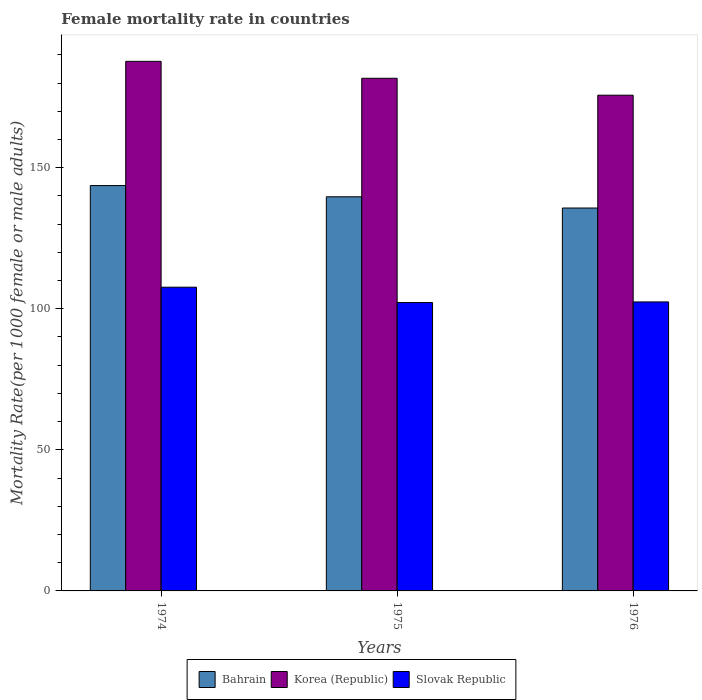How many different coloured bars are there?
Offer a terse response. 3. How many groups of bars are there?
Ensure brevity in your answer.  3. Are the number of bars per tick equal to the number of legend labels?
Offer a very short reply. Yes. How many bars are there on the 2nd tick from the right?
Your answer should be very brief. 3. What is the label of the 3rd group of bars from the left?
Keep it short and to the point. 1976. In how many cases, is the number of bars for a given year not equal to the number of legend labels?
Offer a terse response. 0. What is the female mortality rate in Bahrain in 1975?
Keep it short and to the point. 139.69. Across all years, what is the maximum female mortality rate in Slovak Republic?
Provide a short and direct response. 107.65. Across all years, what is the minimum female mortality rate in Slovak Republic?
Provide a short and direct response. 102.21. In which year was the female mortality rate in Slovak Republic maximum?
Keep it short and to the point. 1974. In which year was the female mortality rate in Bahrain minimum?
Your answer should be very brief. 1976. What is the total female mortality rate in Bahrain in the graph?
Your response must be concise. 419.07. What is the difference between the female mortality rate in Korea (Republic) in 1974 and that in 1975?
Provide a succinct answer. 6. What is the difference between the female mortality rate in Korea (Republic) in 1976 and the female mortality rate in Slovak Republic in 1974?
Offer a terse response. 68.05. What is the average female mortality rate in Slovak Republic per year?
Make the answer very short. 104.09. In the year 1976, what is the difference between the female mortality rate in Korea (Republic) and female mortality rate in Slovak Republic?
Provide a short and direct response. 73.27. In how many years, is the female mortality rate in Korea (Republic) greater than 50?
Offer a terse response. 3. What is the ratio of the female mortality rate in Korea (Republic) in 1975 to that in 1976?
Your answer should be very brief. 1.03. Is the female mortality rate in Slovak Republic in 1975 less than that in 1976?
Provide a succinct answer. Yes. Is the difference between the female mortality rate in Korea (Republic) in 1974 and 1976 greater than the difference between the female mortality rate in Slovak Republic in 1974 and 1976?
Make the answer very short. Yes. What is the difference between the highest and the second highest female mortality rate in Bahrain?
Provide a succinct answer. 3.98. What is the difference between the highest and the lowest female mortality rate in Korea (Republic)?
Offer a terse response. 11.99. What does the 1st bar from the right in 1976 represents?
Provide a succinct answer. Slovak Republic. Is it the case that in every year, the sum of the female mortality rate in Bahrain and female mortality rate in Slovak Republic is greater than the female mortality rate in Korea (Republic)?
Your answer should be very brief. Yes. Are all the bars in the graph horizontal?
Give a very brief answer. No. How many years are there in the graph?
Your answer should be very brief. 3. What is the difference between two consecutive major ticks on the Y-axis?
Keep it short and to the point. 50. Does the graph contain any zero values?
Give a very brief answer. No. Does the graph contain grids?
Your answer should be compact. No. How are the legend labels stacked?
Make the answer very short. Horizontal. What is the title of the graph?
Ensure brevity in your answer.  Female mortality rate in countries. What is the label or title of the X-axis?
Keep it short and to the point. Years. What is the label or title of the Y-axis?
Keep it short and to the point. Mortality Rate(per 1000 female or male adults). What is the Mortality Rate(per 1000 female or male adults) in Bahrain in 1974?
Offer a terse response. 143.67. What is the Mortality Rate(per 1000 female or male adults) of Korea (Republic) in 1974?
Keep it short and to the point. 187.69. What is the Mortality Rate(per 1000 female or male adults) in Slovak Republic in 1974?
Make the answer very short. 107.65. What is the Mortality Rate(per 1000 female or male adults) in Bahrain in 1975?
Your answer should be very brief. 139.69. What is the Mortality Rate(per 1000 female or male adults) in Korea (Republic) in 1975?
Your answer should be compact. 181.69. What is the Mortality Rate(per 1000 female or male adults) of Slovak Republic in 1975?
Your answer should be compact. 102.21. What is the Mortality Rate(per 1000 female or male adults) of Bahrain in 1976?
Offer a very short reply. 135.71. What is the Mortality Rate(per 1000 female or male adults) of Korea (Republic) in 1976?
Offer a terse response. 175.7. What is the Mortality Rate(per 1000 female or male adults) in Slovak Republic in 1976?
Your response must be concise. 102.43. Across all years, what is the maximum Mortality Rate(per 1000 female or male adults) of Bahrain?
Make the answer very short. 143.67. Across all years, what is the maximum Mortality Rate(per 1000 female or male adults) in Korea (Republic)?
Your response must be concise. 187.69. Across all years, what is the maximum Mortality Rate(per 1000 female or male adults) in Slovak Republic?
Your answer should be compact. 107.65. Across all years, what is the minimum Mortality Rate(per 1000 female or male adults) of Bahrain?
Make the answer very short. 135.71. Across all years, what is the minimum Mortality Rate(per 1000 female or male adults) of Korea (Republic)?
Give a very brief answer. 175.7. Across all years, what is the minimum Mortality Rate(per 1000 female or male adults) of Slovak Republic?
Your answer should be very brief. 102.21. What is the total Mortality Rate(per 1000 female or male adults) in Bahrain in the graph?
Provide a short and direct response. 419.07. What is the total Mortality Rate(per 1000 female or male adults) of Korea (Republic) in the graph?
Your answer should be compact. 545.08. What is the total Mortality Rate(per 1000 female or male adults) in Slovak Republic in the graph?
Your answer should be compact. 312.28. What is the difference between the Mortality Rate(per 1000 female or male adults) of Bahrain in 1974 and that in 1975?
Give a very brief answer. 3.98. What is the difference between the Mortality Rate(per 1000 female or male adults) of Korea (Republic) in 1974 and that in 1975?
Ensure brevity in your answer.  6. What is the difference between the Mortality Rate(per 1000 female or male adults) in Slovak Republic in 1974 and that in 1975?
Provide a short and direct response. 5.43. What is the difference between the Mortality Rate(per 1000 female or male adults) in Bahrain in 1974 and that in 1976?
Your response must be concise. 7.97. What is the difference between the Mortality Rate(per 1000 female or male adults) of Korea (Republic) in 1974 and that in 1976?
Give a very brief answer. 11.99. What is the difference between the Mortality Rate(per 1000 female or male adults) in Slovak Republic in 1974 and that in 1976?
Ensure brevity in your answer.  5.22. What is the difference between the Mortality Rate(per 1000 female or male adults) in Bahrain in 1975 and that in 1976?
Offer a very short reply. 3.98. What is the difference between the Mortality Rate(per 1000 female or male adults) in Korea (Republic) in 1975 and that in 1976?
Offer a terse response. 6. What is the difference between the Mortality Rate(per 1000 female or male adults) in Slovak Republic in 1975 and that in 1976?
Keep it short and to the point. -0.22. What is the difference between the Mortality Rate(per 1000 female or male adults) in Bahrain in 1974 and the Mortality Rate(per 1000 female or male adults) in Korea (Republic) in 1975?
Offer a terse response. -38.02. What is the difference between the Mortality Rate(per 1000 female or male adults) of Bahrain in 1974 and the Mortality Rate(per 1000 female or male adults) of Slovak Republic in 1975?
Your answer should be very brief. 41.46. What is the difference between the Mortality Rate(per 1000 female or male adults) in Korea (Republic) in 1974 and the Mortality Rate(per 1000 female or male adults) in Slovak Republic in 1975?
Keep it short and to the point. 85.48. What is the difference between the Mortality Rate(per 1000 female or male adults) in Bahrain in 1974 and the Mortality Rate(per 1000 female or male adults) in Korea (Republic) in 1976?
Ensure brevity in your answer.  -32.02. What is the difference between the Mortality Rate(per 1000 female or male adults) in Bahrain in 1974 and the Mortality Rate(per 1000 female or male adults) in Slovak Republic in 1976?
Offer a terse response. 41.25. What is the difference between the Mortality Rate(per 1000 female or male adults) of Korea (Republic) in 1974 and the Mortality Rate(per 1000 female or male adults) of Slovak Republic in 1976?
Ensure brevity in your answer.  85.26. What is the difference between the Mortality Rate(per 1000 female or male adults) of Bahrain in 1975 and the Mortality Rate(per 1000 female or male adults) of Korea (Republic) in 1976?
Provide a succinct answer. -36.01. What is the difference between the Mortality Rate(per 1000 female or male adults) in Bahrain in 1975 and the Mortality Rate(per 1000 female or male adults) in Slovak Republic in 1976?
Provide a short and direct response. 37.26. What is the difference between the Mortality Rate(per 1000 female or male adults) in Korea (Republic) in 1975 and the Mortality Rate(per 1000 female or male adults) in Slovak Republic in 1976?
Your answer should be very brief. 79.27. What is the average Mortality Rate(per 1000 female or male adults) in Bahrain per year?
Make the answer very short. 139.69. What is the average Mortality Rate(per 1000 female or male adults) of Korea (Republic) per year?
Provide a short and direct response. 181.69. What is the average Mortality Rate(per 1000 female or male adults) of Slovak Republic per year?
Your answer should be compact. 104.09. In the year 1974, what is the difference between the Mortality Rate(per 1000 female or male adults) in Bahrain and Mortality Rate(per 1000 female or male adults) in Korea (Republic)?
Your answer should be very brief. -44.02. In the year 1974, what is the difference between the Mortality Rate(per 1000 female or male adults) of Bahrain and Mortality Rate(per 1000 female or male adults) of Slovak Republic?
Give a very brief answer. 36.03. In the year 1974, what is the difference between the Mortality Rate(per 1000 female or male adults) of Korea (Republic) and Mortality Rate(per 1000 female or male adults) of Slovak Republic?
Your response must be concise. 80.04. In the year 1975, what is the difference between the Mortality Rate(per 1000 female or male adults) in Bahrain and Mortality Rate(per 1000 female or male adults) in Korea (Republic)?
Your answer should be compact. -42. In the year 1975, what is the difference between the Mortality Rate(per 1000 female or male adults) in Bahrain and Mortality Rate(per 1000 female or male adults) in Slovak Republic?
Provide a short and direct response. 37.48. In the year 1975, what is the difference between the Mortality Rate(per 1000 female or male adults) in Korea (Republic) and Mortality Rate(per 1000 female or male adults) in Slovak Republic?
Your answer should be compact. 79.48. In the year 1976, what is the difference between the Mortality Rate(per 1000 female or male adults) of Bahrain and Mortality Rate(per 1000 female or male adults) of Korea (Republic)?
Provide a succinct answer. -39.99. In the year 1976, what is the difference between the Mortality Rate(per 1000 female or male adults) in Bahrain and Mortality Rate(per 1000 female or male adults) in Slovak Republic?
Your answer should be very brief. 33.28. In the year 1976, what is the difference between the Mortality Rate(per 1000 female or male adults) in Korea (Republic) and Mortality Rate(per 1000 female or male adults) in Slovak Republic?
Make the answer very short. 73.27. What is the ratio of the Mortality Rate(per 1000 female or male adults) of Bahrain in 1974 to that in 1975?
Provide a succinct answer. 1.03. What is the ratio of the Mortality Rate(per 1000 female or male adults) in Korea (Republic) in 1974 to that in 1975?
Provide a succinct answer. 1.03. What is the ratio of the Mortality Rate(per 1000 female or male adults) of Slovak Republic in 1974 to that in 1975?
Make the answer very short. 1.05. What is the ratio of the Mortality Rate(per 1000 female or male adults) in Bahrain in 1974 to that in 1976?
Provide a short and direct response. 1.06. What is the ratio of the Mortality Rate(per 1000 female or male adults) of Korea (Republic) in 1974 to that in 1976?
Your answer should be compact. 1.07. What is the ratio of the Mortality Rate(per 1000 female or male adults) in Slovak Republic in 1974 to that in 1976?
Your answer should be very brief. 1.05. What is the ratio of the Mortality Rate(per 1000 female or male adults) in Bahrain in 1975 to that in 1976?
Ensure brevity in your answer.  1.03. What is the ratio of the Mortality Rate(per 1000 female or male adults) in Korea (Republic) in 1975 to that in 1976?
Your answer should be compact. 1.03. What is the difference between the highest and the second highest Mortality Rate(per 1000 female or male adults) of Bahrain?
Provide a succinct answer. 3.98. What is the difference between the highest and the second highest Mortality Rate(per 1000 female or male adults) of Korea (Republic)?
Offer a terse response. 6. What is the difference between the highest and the second highest Mortality Rate(per 1000 female or male adults) in Slovak Republic?
Give a very brief answer. 5.22. What is the difference between the highest and the lowest Mortality Rate(per 1000 female or male adults) in Bahrain?
Make the answer very short. 7.97. What is the difference between the highest and the lowest Mortality Rate(per 1000 female or male adults) of Korea (Republic)?
Offer a very short reply. 11.99. What is the difference between the highest and the lowest Mortality Rate(per 1000 female or male adults) of Slovak Republic?
Offer a terse response. 5.43. 